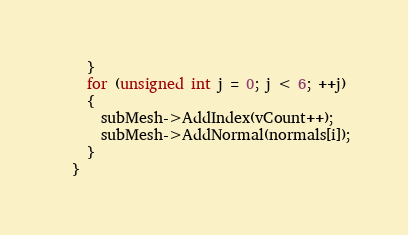<code> <loc_0><loc_0><loc_500><loc_500><_C++_>    }
    for (unsigned int j = 0; j < 6; ++j)
    {
      subMesh->AddIndex(vCount++);
      subMesh->AddNormal(normals[i]);
    }
  }
</code> 